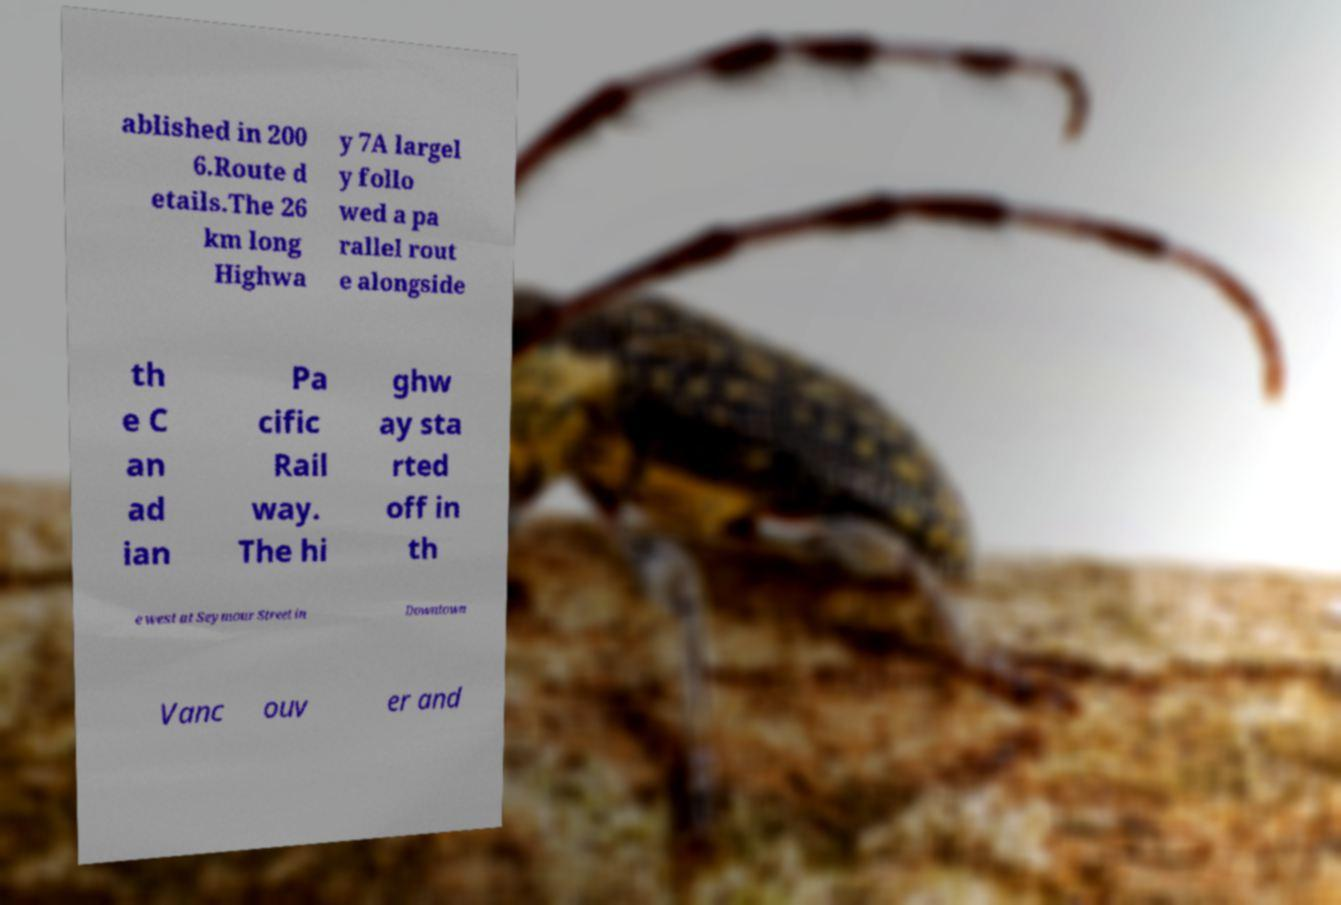What messages or text are displayed in this image? I need them in a readable, typed format. ablished in 200 6.Route d etails.The 26 km long Highwa y 7A largel y follo wed a pa rallel rout e alongside th e C an ad ian Pa cific Rail way. The hi ghw ay sta rted off in th e west at Seymour Street in Downtown Vanc ouv er and 